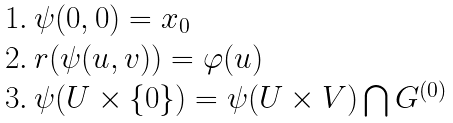<formula> <loc_0><loc_0><loc_500><loc_500>\begin{array} { l } 1 . \ \psi ( 0 , 0 ) = x _ { 0 } \\ 2 . \ r ( \psi ( u , v ) ) = \varphi ( u ) \\ 3 . \ \psi ( U \times \{ 0 \} ) = \psi ( U \times V ) \bigcap G ^ { ( 0 ) } \end{array}</formula> 